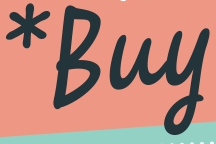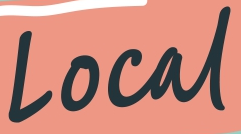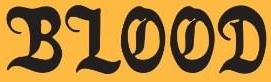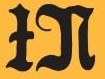What words can you see in these images in sequence, separated by a semicolon? *Buy; Local; BLOOD; IN 